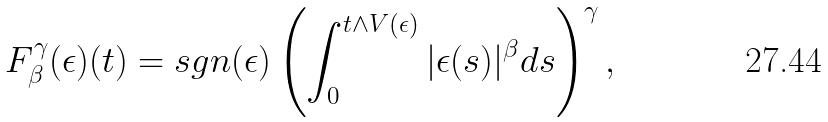Convert formula to latex. <formula><loc_0><loc_0><loc_500><loc_500>F ^ { \gamma } _ { \beta } ( \epsilon ) ( t ) = s g n ( \epsilon ) \left ( \int _ { 0 } ^ { t \land V ( \epsilon ) } | \epsilon ( s ) | ^ { \beta } d s \right ) ^ { \gamma } ,</formula> 